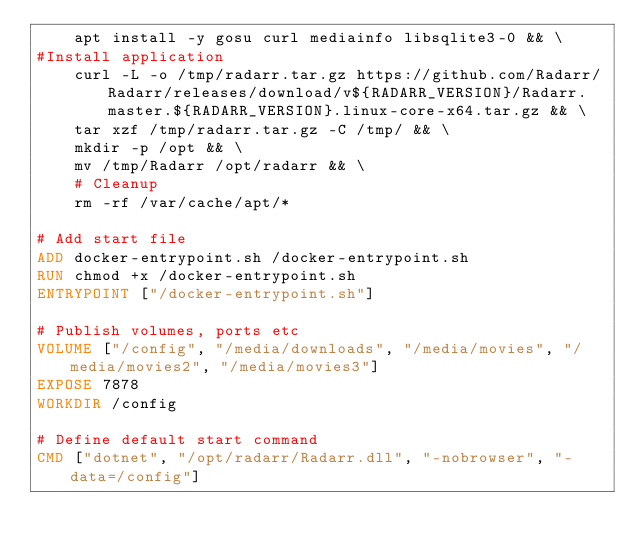Convert code to text. <code><loc_0><loc_0><loc_500><loc_500><_Dockerfile_>    apt install -y gosu curl mediainfo libsqlite3-0 && \
#Install application
    curl -L -o /tmp/radarr.tar.gz https://github.com/Radarr/Radarr/releases/download/v${RADARR_VERSION}/Radarr.master.${RADARR_VERSION}.linux-core-x64.tar.gz && \
    tar xzf /tmp/radarr.tar.gz -C /tmp/ && \
    mkdir -p /opt && \
    mv /tmp/Radarr /opt/radarr && \
    # Cleanup
    rm -rf /var/cache/apt/*

# Add start file
ADD docker-entrypoint.sh /docker-entrypoint.sh
RUN chmod +x /docker-entrypoint.sh
ENTRYPOINT ["/docker-entrypoint.sh"]

# Publish volumes, ports etc
VOLUME ["/config", "/media/downloads", "/media/movies", "/media/movies2", "/media/movies3"]
EXPOSE 7878
WORKDIR /config

# Define default start command
CMD ["dotnet", "/opt/radarr/Radarr.dll", "-nobrowser", "-data=/config"]
</code> 